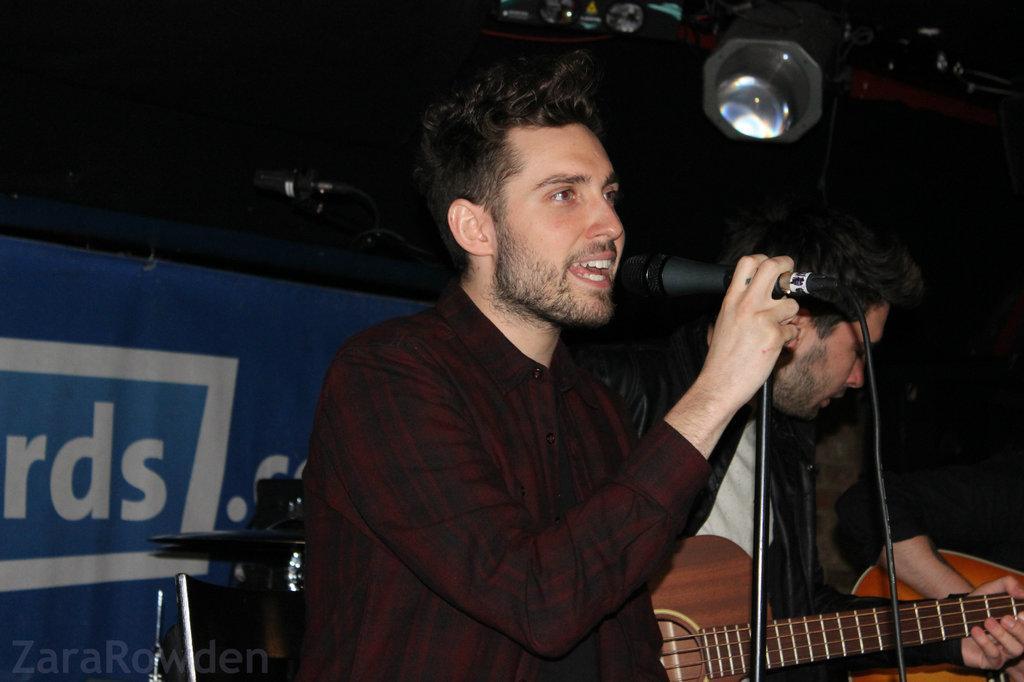How would you summarize this image in a sentence or two? In this image we can see a two persons. The person is holding a mic. 